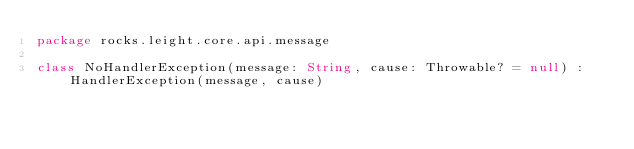<code> <loc_0><loc_0><loc_500><loc_500><_Kotlin_>package rocks.leight.core.api.message

class NoHandlerException(message: String, cause: Throwable? = null) : HandlerException(message, cause)
</code> 